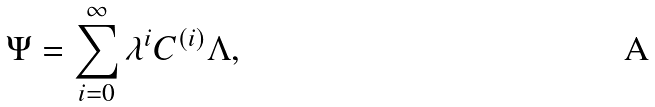Convert formula to latex. <formula><loc_0><loc_0><loc_500><loc_500>\Psi = \sum _ { i = 0 } ^ { \infty } \lambda ^ { i } C ^ { ( i ) } \Lambda ,</formula> 